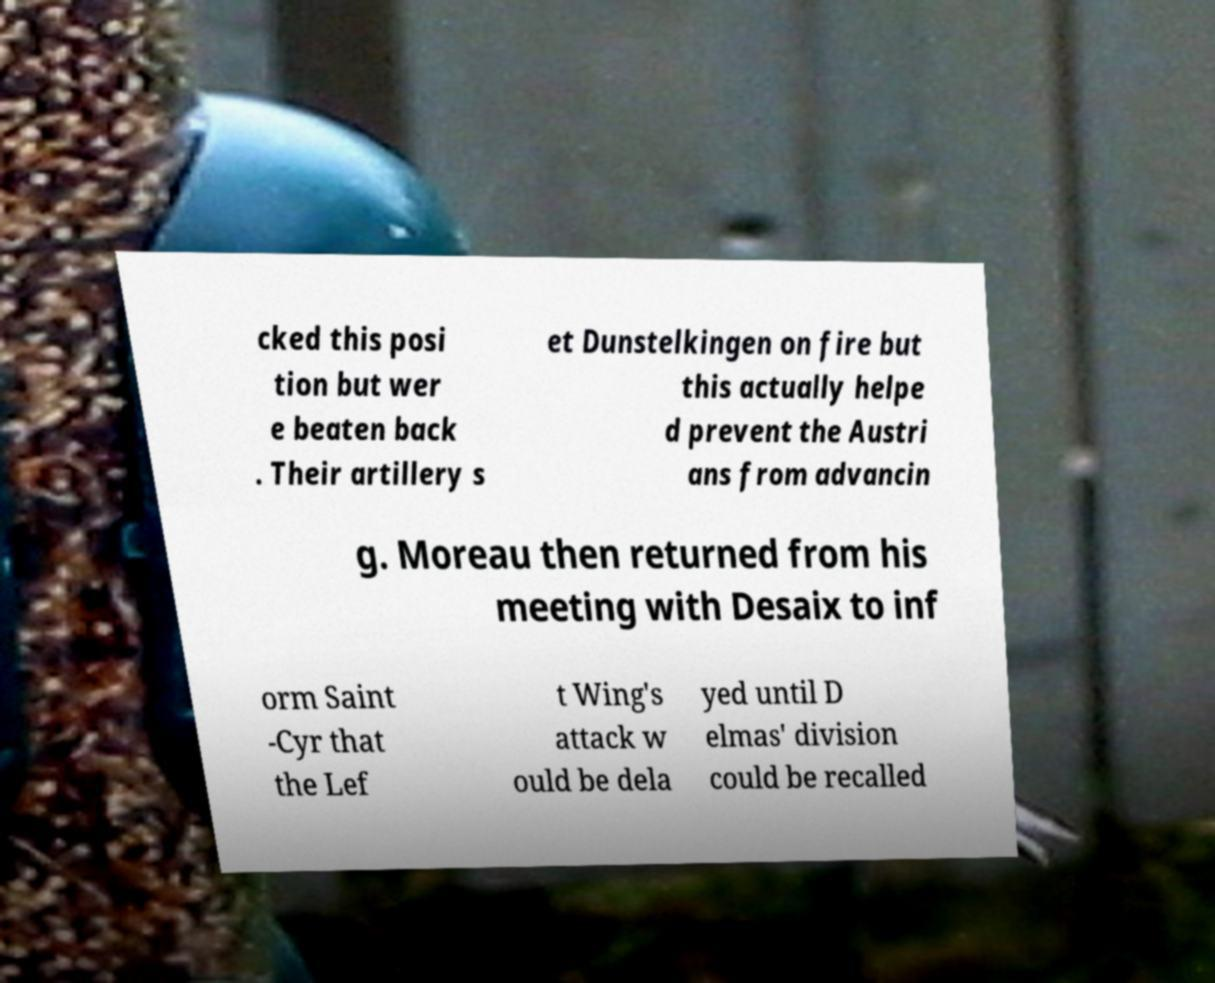Please read and relay the text visible in this image. What does it say? cked this posi tion but wer e beaten back . Their artillery s et Dunstelkingen on fire but this actually helpe d prevent the Austri ans from advancin g. Moreau then returned from his meeting with Desaix to inf orm Saint -Cyr that the Lef t Wing's attack w ould be dela yed until D elmas' division could be recalled 